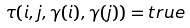<formula> <loc_0><loc_0><loc_500><loc_500>\tau ( i , j , \gamma ( i ) , \gamma ( j ) ) = t r u e</formula> 